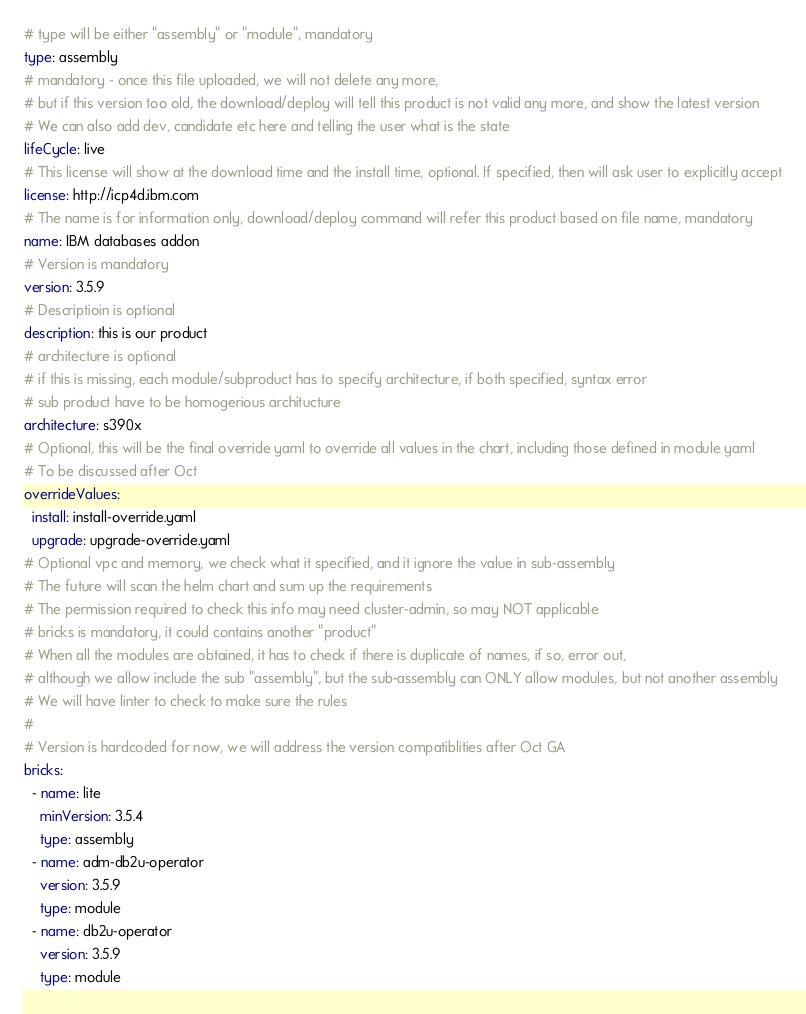<code> <loc_0><loc_0><loc_500><loc_500><_YAML_># type will be either "assembly" or "module", mandatory
type: assembly
# mandatory - once this file uploaded, we will not delete any more, 
# but if this version too old, the download/deploy will tell this product is not valid any more, and show the latest version
# We can also add dev, candidate etc here and telling the user what is the state
lifeCycle: live
# This license will show at the download time and the install time, optional. If specified, then will ask user to explicitly accept
license: http://icp4d.ibm.com
# The name is for information only, download/deploy command will refer this product based on file name, mandatory
name: IBM databases addon
# Version is mandatory
version: 3.5.9
# Descriptioin is optional
description: this is our product
# architecture is optional
# if this is missing, each module/subproduct has to specify architecture, if both specified, syntax error
# sub product have to be homogerious architucture
architecture: s390x
# Optional, this will be the final override yaml to override all values in the chart, including those defined in module yaml
# To be discussed after Oct
overrideValues:
  install: install-override.yaml
  upgrade: upgrade-override.yaml
# Optional vpc and memory, we check what it specified, and it ignore the value in sub-assembly
# The future will scan the helm chart and sum up the requirements
# The permission required to check this info may need cluster-admin, so may NOT applicable
# bricks is mandatory, it could contains another "product"
# When all the modules are obtained, it has to check if there is duplicate of names, if so, error out, 
# although we allow include the sub "assembly", but the sub-assembly can ONLY allow modules, but not another assembly
# We will have linter to check to make sure the rules
#
# Version is hardcoded for now, we will address the version compatiblities after Oct GA
bricks:
  - name: lite
    minVersion: 3.5.4
    type: assembly
  - name: adm-db2u-operator
    version: 3.5.9
    type: module
  - name: db2u-operator
    version: 3.5.9
    type: module</code> 